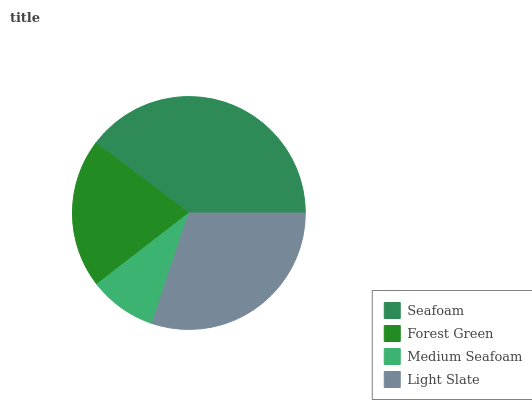Is Medium Seafoam the minimum?
Answer yes or no. Yes. Is Seafoam the maximum?
Answer yes or no. Yes. Is Forest Green the minimum?
Answer yes or no. No. Is Forest Green the maximum?
Answer yes or no. No. Is Seafoam greater than Forest Green?
Answer yes or no. Yes. Is Forest Green less than Seafoam?
Answer yes or no. Yes. Is Forest Green greater than Seafoam?
Answer yes or no. No. Is Seafoam less than Forest Green?
Answer yes or no. No. Is Light Slate the high median?
Answer yes or no. Yes. Is Forest Green the low median?
Answer yes or no. Yes. Is Medium Seafoam the high median?
Answer yes or no. No. Is Medium Seafoam the low median?
Answer yes or no. No. 